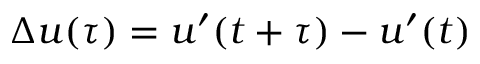Convert formula to latex. <formula><loc_0><loc_0><loc_500><loc_500>\Delta u ( \tau ) = u ^ { \prime } ( t + \tau ) - u ^ { \prime } ( t )</formula> 